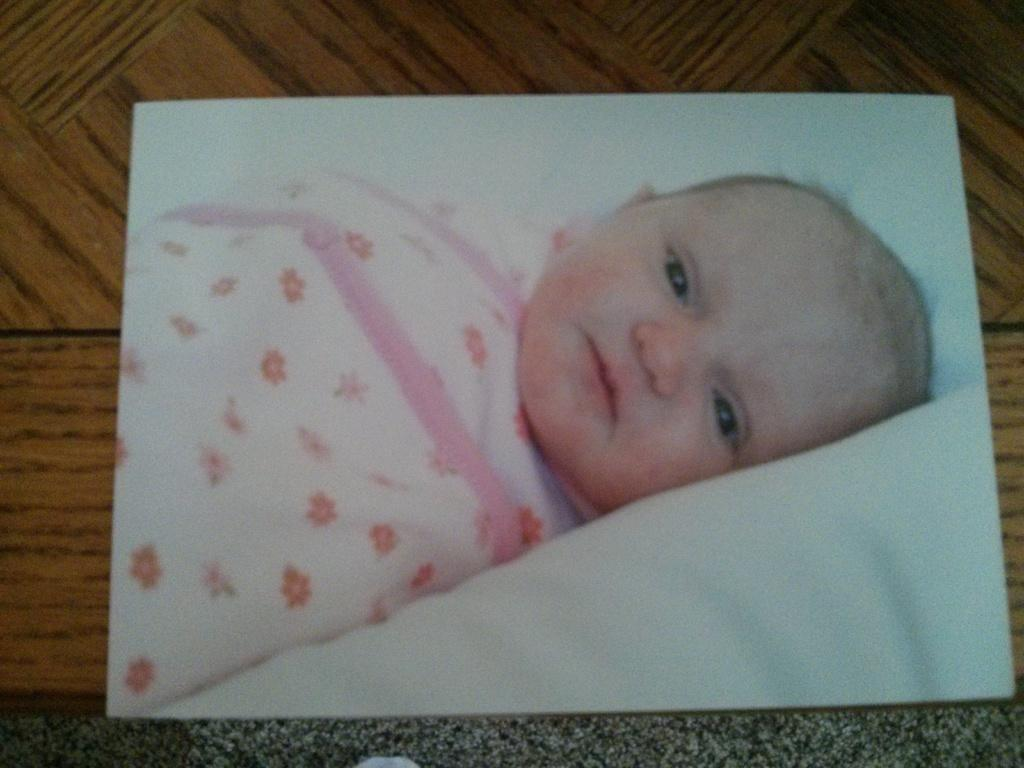What is the main subject of the frame in the image? The frame contains a picture of a baby. What is the baby doing in the picture? The baby is lying on a bed in the picture. How is the frame positioned in the image? The frame is placed on a wooden board. What type of paper is the baby using to write on in the picture? There is no paper or writing activity present in the image; the baby is simply lying on a bed in the picture. 